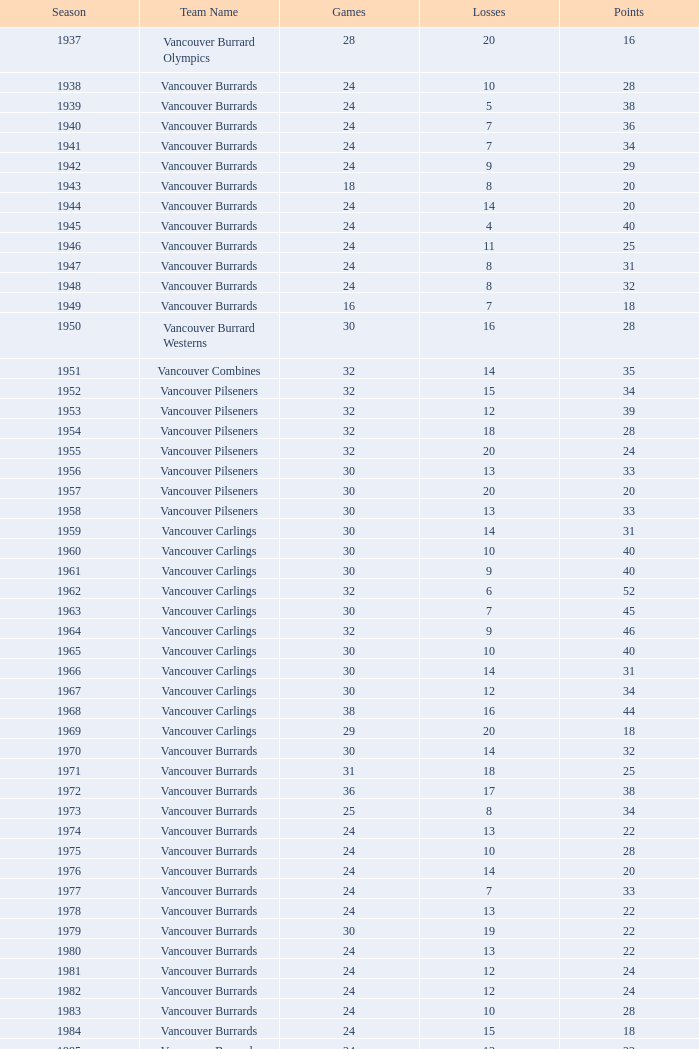What is the overall point count for the vancouver burrards when they have less than 9 losses and over 24 games played? 1.0. 